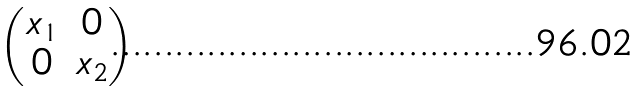Convert formula to latex. <formula><loc_0><loc_0><loc_500><loc_500>\begin{pmatrix} x _ { 1 } & 0 \\ 0 & x _ { 2 } \end{pmatrix}</formula> 